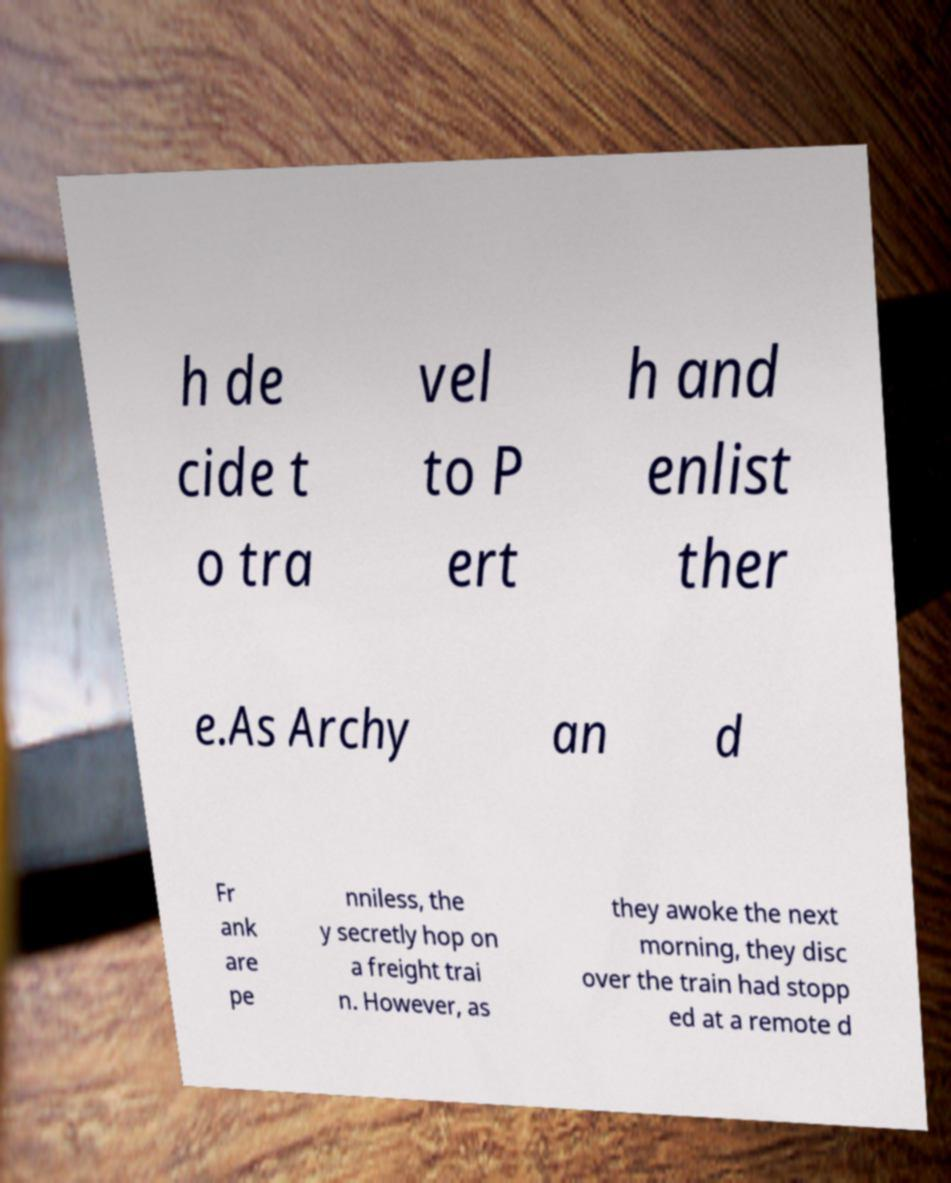Can you read and provide the text displayed in the image?This photo seems to have some interesting text. Can you extract and type it out for me? h de cide t o tra vel to P ert h and enlist ther e.As Archy an d Fr ank are pe nniless, the y secretly hop on a freight trai n. However, as they awoke the next morning, they disc over the train had stopp ed at a remote d 